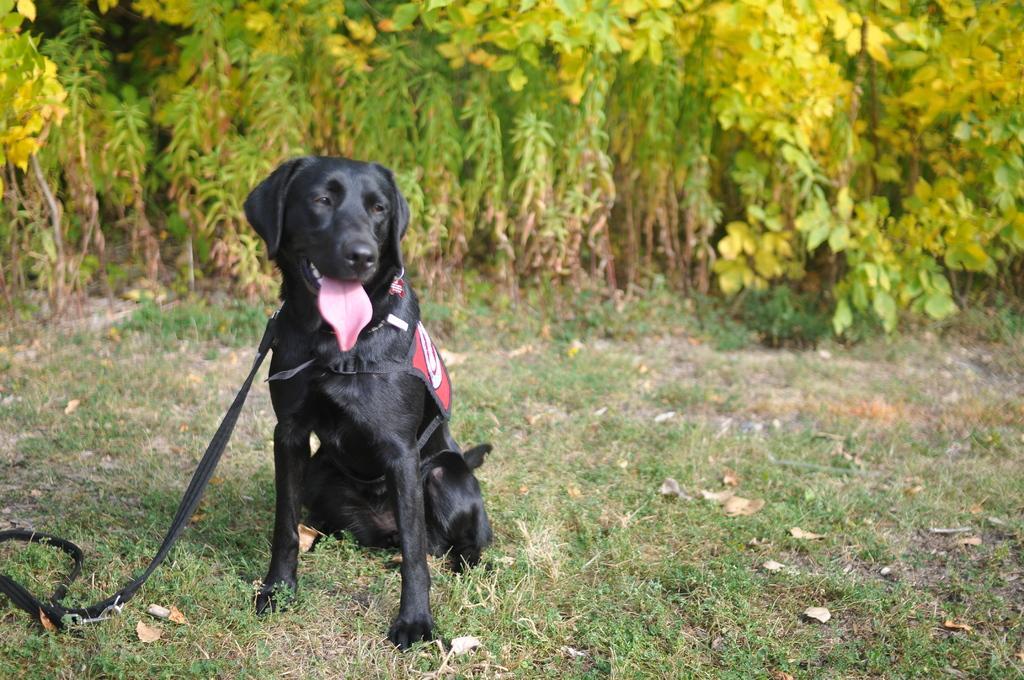Describe this image in one or two sentences. In this picture, we see a black dog and it is putting its tongue out. We see the leash of the dog in black color. At the bottom, we see the grass. There are trees in the background. 